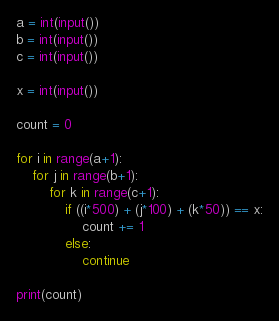<code> <loc_0><loc_0><loc_500><loc_500><_Python_>a = int(input())
b = int(input())
c = int(input())

x = int(input())

count = 0

for i in range(a+1):
    for j in range(b+1):
        for k in range(c+1):
            if ((i*500) + (j*100) + (k*50)) == x:
                count += 1
            else:
                continue

print(count)</code> 